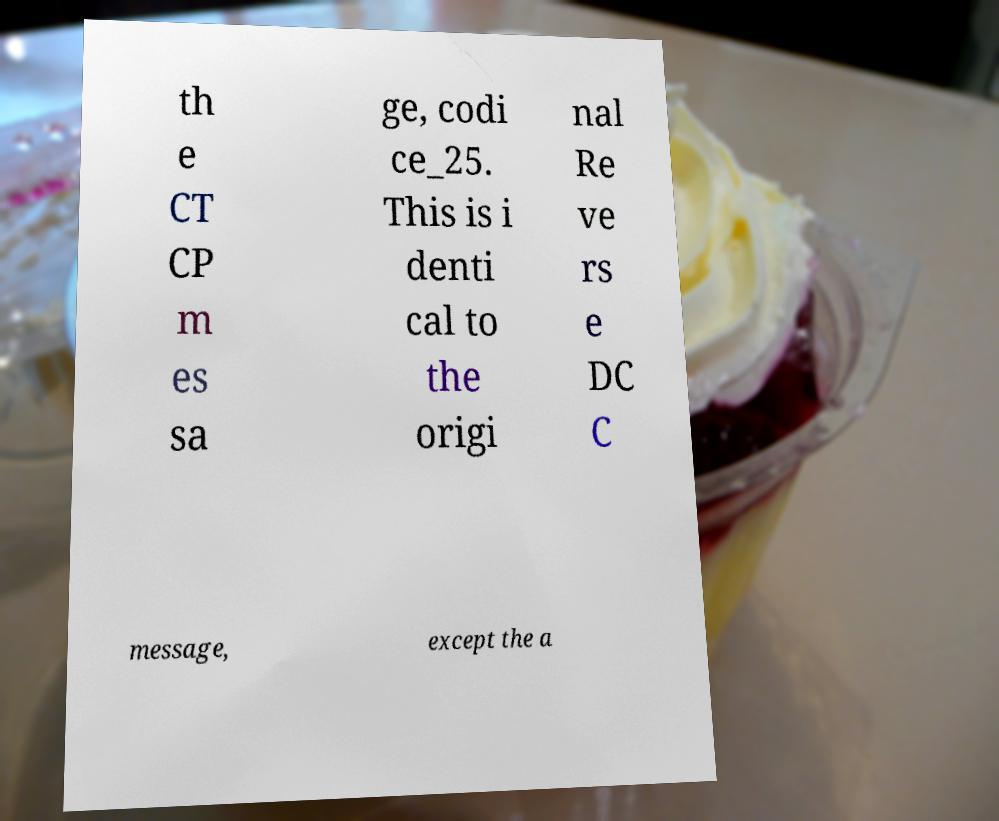Can you read and provide the text displayed in the image?This photo seems to have some interesting text. Can you extract and type it out for me? th e CT CP m es sa ge, codi ce_25. This is i denti cal to the origi nal Re ve rs e DC C message, except the a 